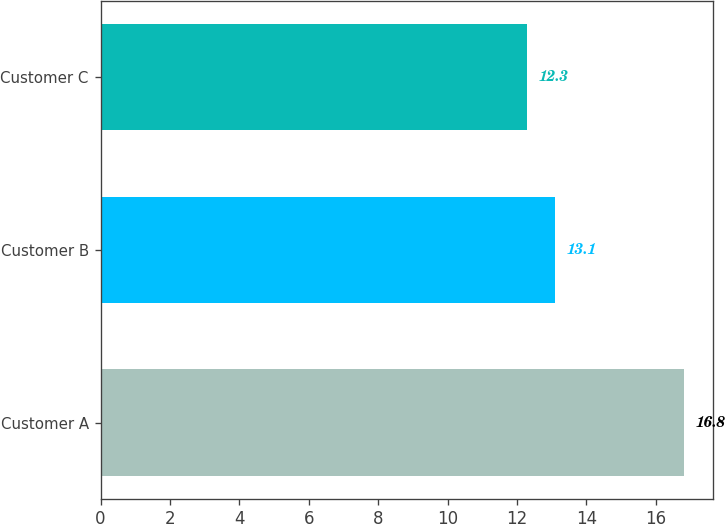Convert chart to OTSL. <chart><loc_0><loc_0><loc_500><loc_500><bar_chart><fcel>Customer A<fcel>Customer B<fcel>Customer C<nl><fcel>16.8<fcel>13.1<fcel>12.3<nl></chart> 